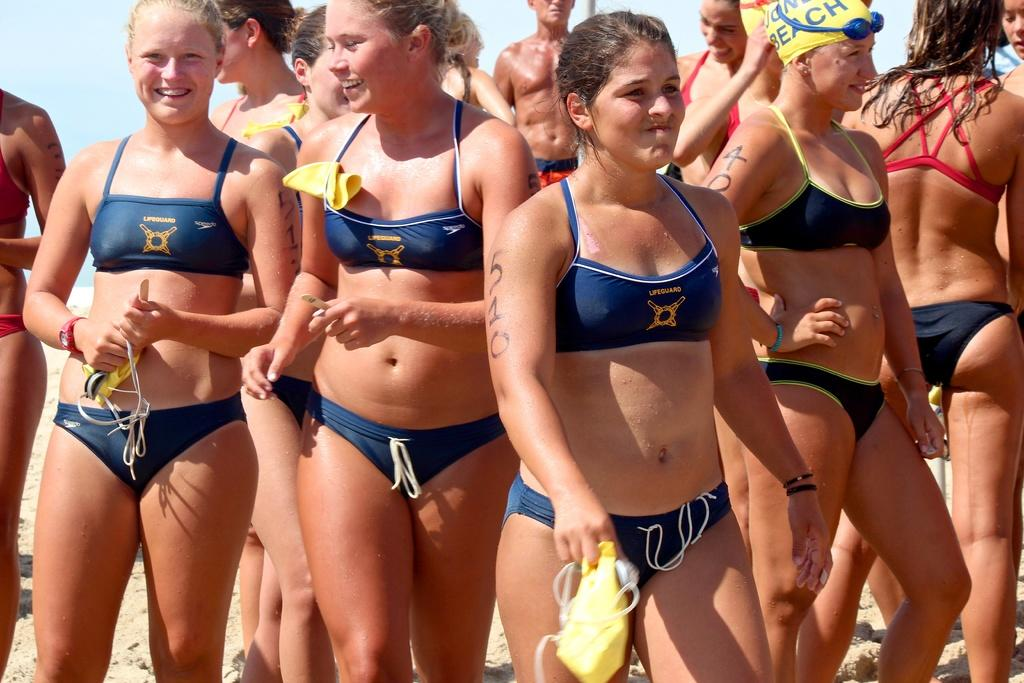What can be seen in the image? There is a group of women in the image. Where are the women standing? The women are standing on sand. What are the women wearing? The women are wearing swim costumes. What expression do the women have? The women are smiling. What type of wine is being served at the mailbox in the image? There is no mailbox or wine present in the image; it features a group of women standing on sand and wearing swim costumes. 